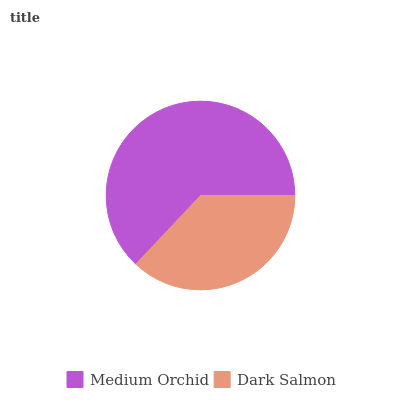Is Dark Salmon the minimum?
Answer yes or no. Yes. Is Medium Orchid the maximum?
Answer yes or no. Yes. Is Dark Salmon the maximum?
Answer yes or no. No. Is Medium Orchid greater than Dark Salmon?
Answer yes or no. Yes. Is Dark Salmon less than Medium Orchid?
Answer yes or no. Yes. Is Dark Salmon greater than Medium Orchid?
Answer yes or no. No. Is Medium Orchid less than Dark Salmon?
Answer yes or no. No. Is Medium Orchid the high median?
Answer yes or no. Yes. Is Dark Salmon the low median?
Answer yes or no. Yes. Is Dark Salmon the high median?
Answer yes or no. No. Is Medium Orchid the low median?
Answer yes or no. No. 